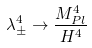Convert formula to latex. <formula><loc_0><loc_0><loc_500><loc_500>\lambda _ { \pm } ^ { 4 } \rightarrow \frac { M _ { P l } ^ { 4 } } { H ^ { 4 } }</formula> 